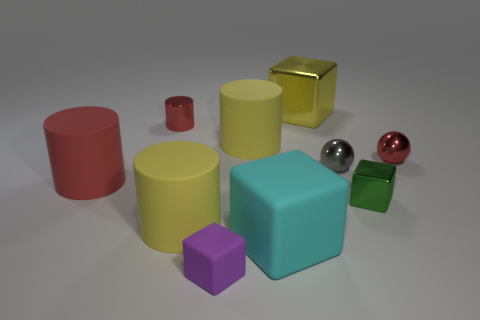Subtract 1 blocks. How many blocks are left? 3 Subtract all blue spheres. Subtract all gray cubes. How many spheres are left? 2 Subtract all cylinders. How many objects are left? 6 Subtract 0 brown cylinders. How many objects are left? 10 Subtract all red rubber objects. Subtract all metallic spheres. How many objects are left? 7 Add 9 tiny cylinders. How many tiny cylinders are left? 10 Add 3 green blocks. How many green blocks exist? 4 